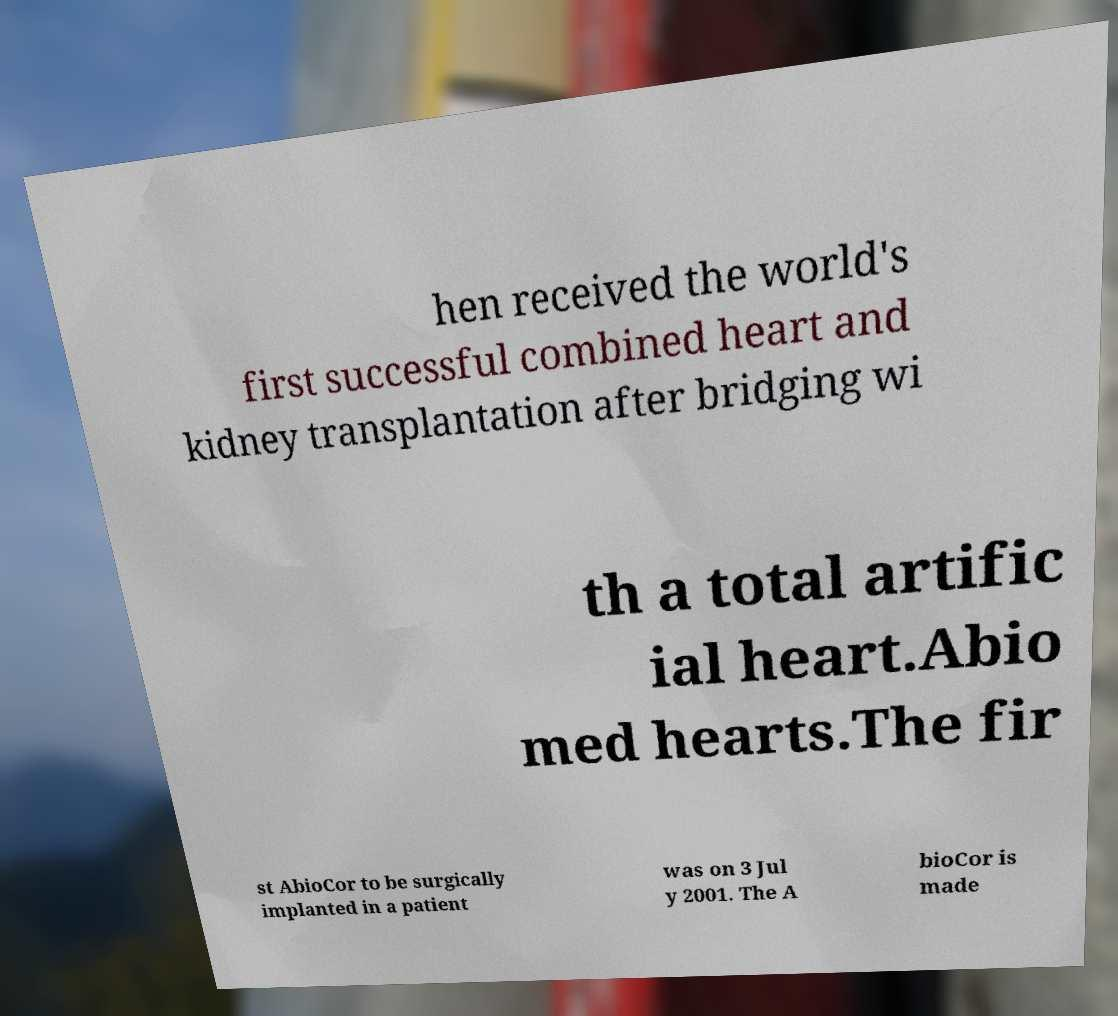Can you read and provide the text displayed in the image?This photo seems to have some interesting text. Can you extract and type it out for me? hen received the world's first successful combined heart and kidney transplantation after bridging wi th a total artific ial heart.Abio med hearts.The fir st AbioCor to be surgically implanted in a patient was on 3 Jul y 2001. The A bioCor is made 